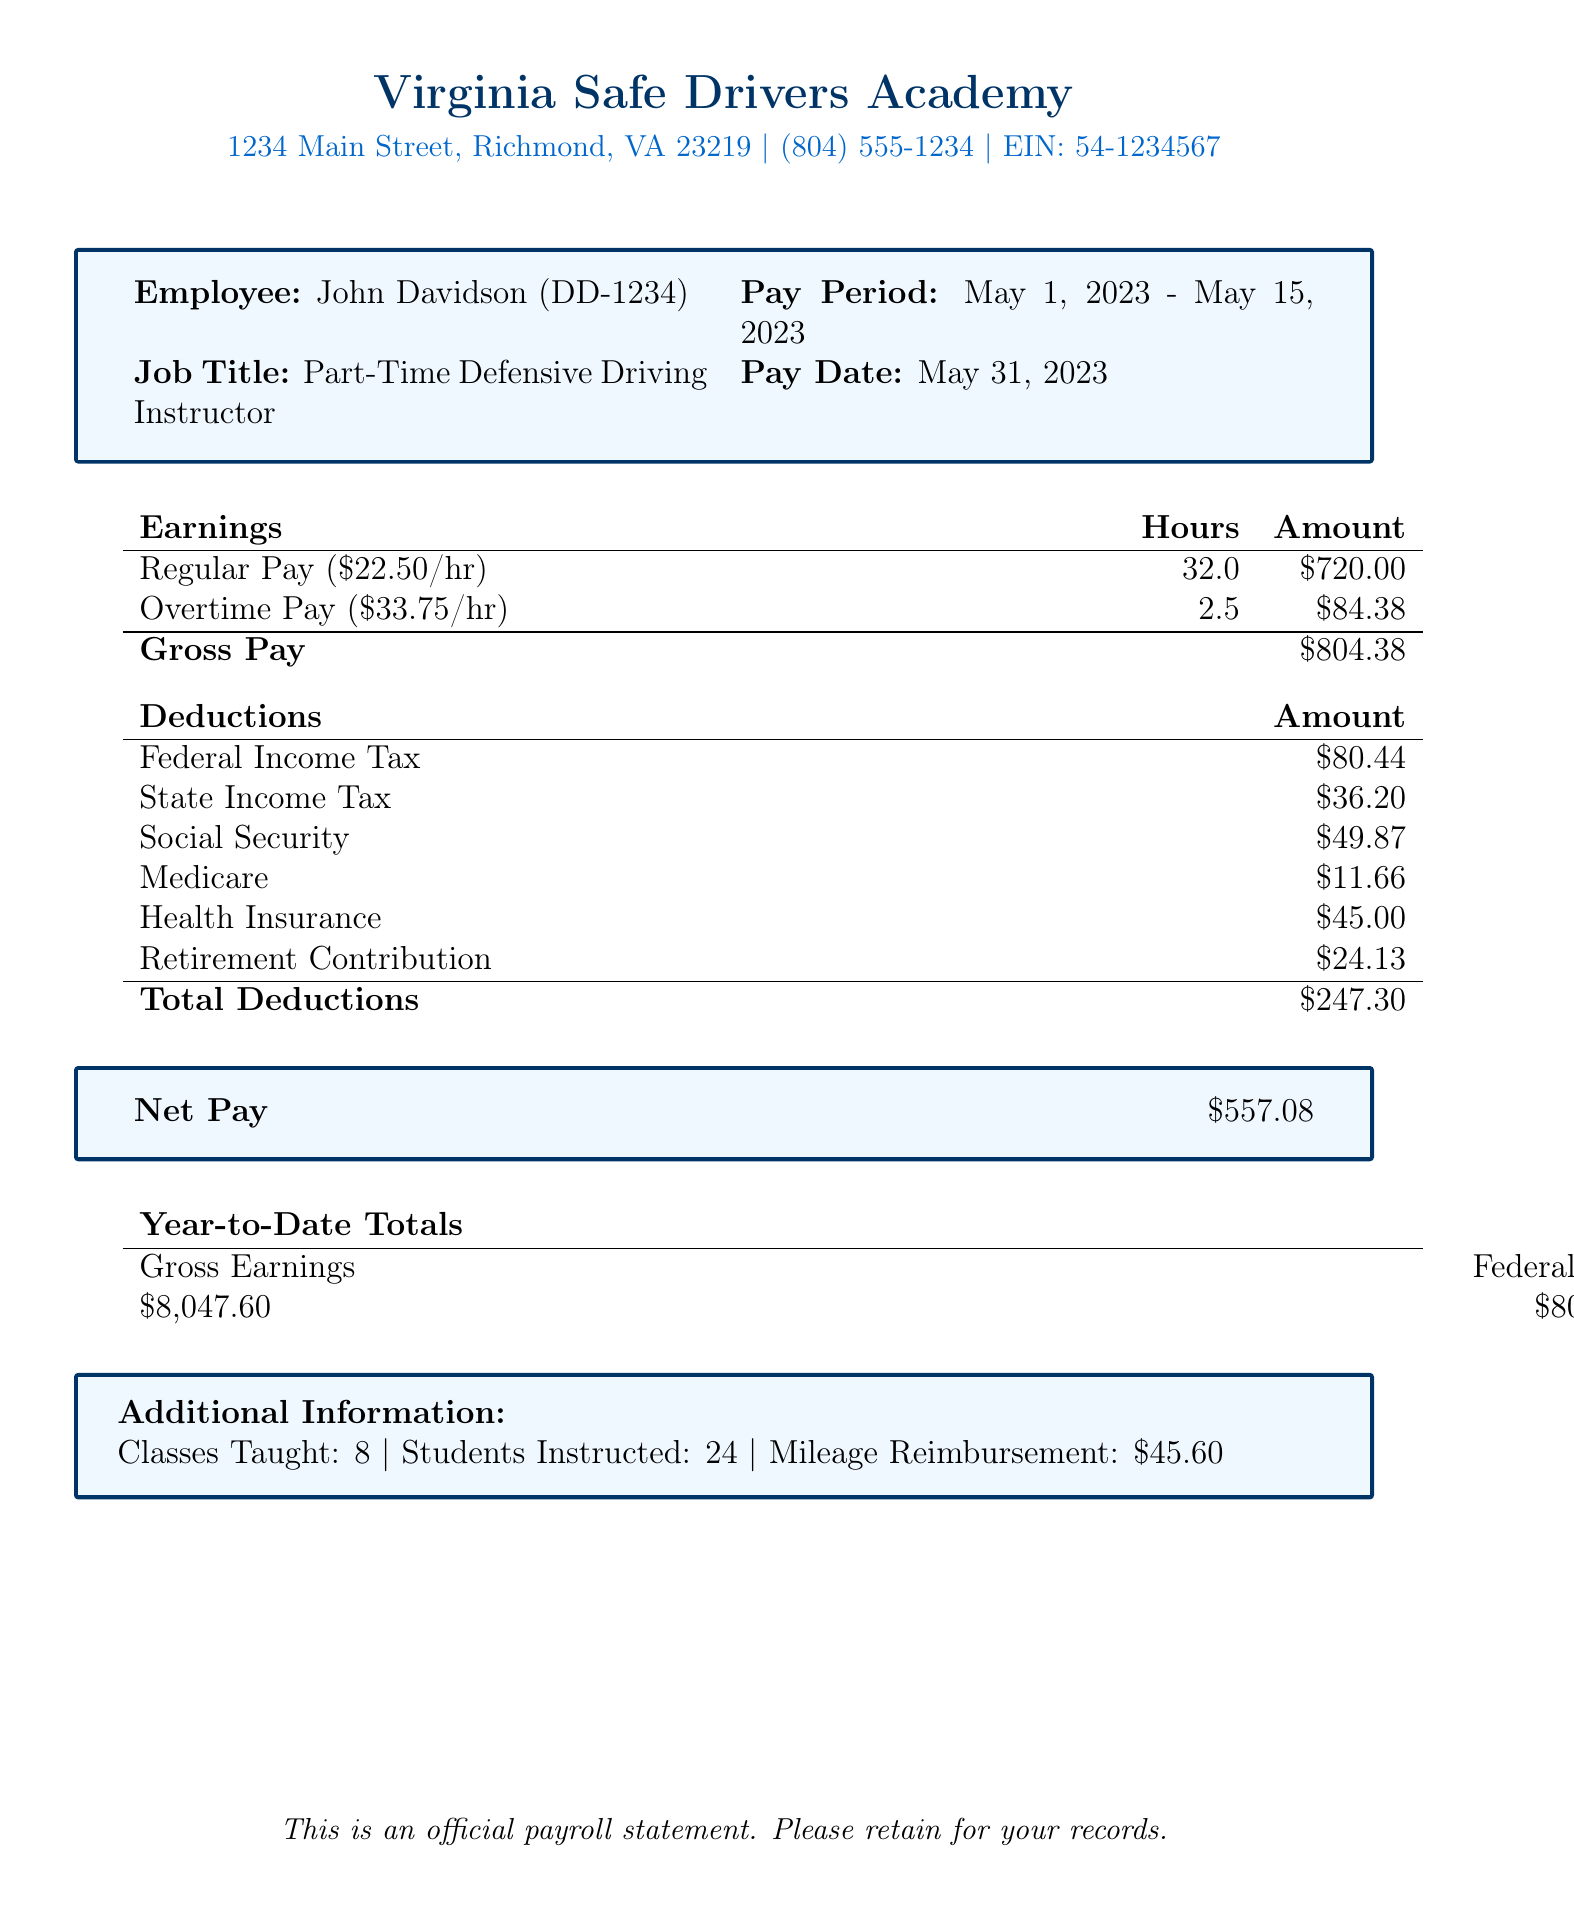What is the employee's name? The name of the employee is provided directly in the document.
Answer: John Davidson What is the total gross pay? The total gross pay is calculated by adding regular pay and overtime pay.
Answer: 804.38 How many regular hours did the employee work? The document specifies the regular hours worked by the employee.
Answer: 32 What is the amount for federal income tax deduction? The amount for the federal income tax is listed under deductions in the document.
Answer: 80.44 What is the year-to-date gross earnings? The year-to-date gross earnings are given explicitly in the document.
Answer: 8047.60 How many classes did the instructor teach? The number of classes taught is indicated in the additional information section of the document.
Answer: 8 What is the next pay date? The document mentions the next pay date clearly.
Answer: May 31, 2023 What is the hourly rate for overtime pay? The overtime pay rate can be calculated by taking the hourly rate and multiplying it by 1.5.
Answer: 33.75 What is the net pay after deductions? The net pay is explicitly stated in the document after deductions are accounted for.
Answer: 557.08 